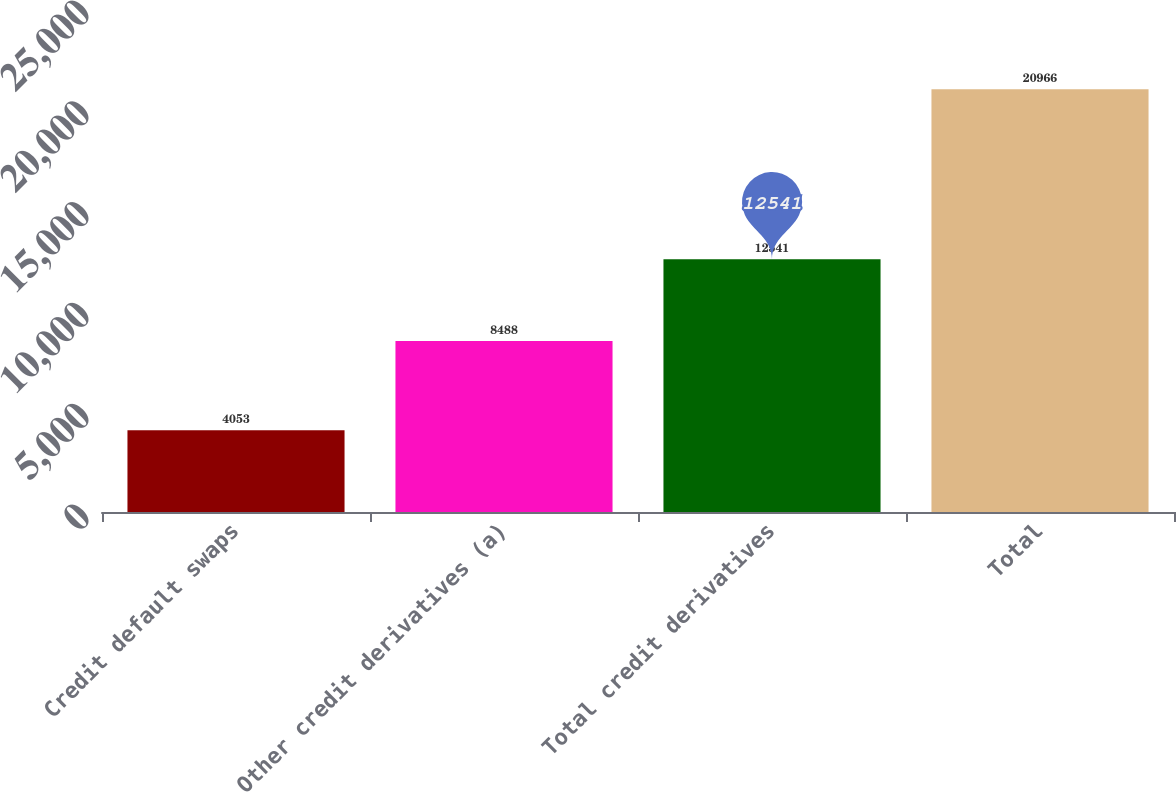<chart> <loc_0><loc_0><loc_500><loc_500><bar_chart><fcel>Credit default swaps<fcel>Other credit derivatives (a)<fcel>Total credit derivatives<fcel>Total<nl><fcel>4053<fcel>8488<fcel>12541<fcel>20966<nl></chart> 